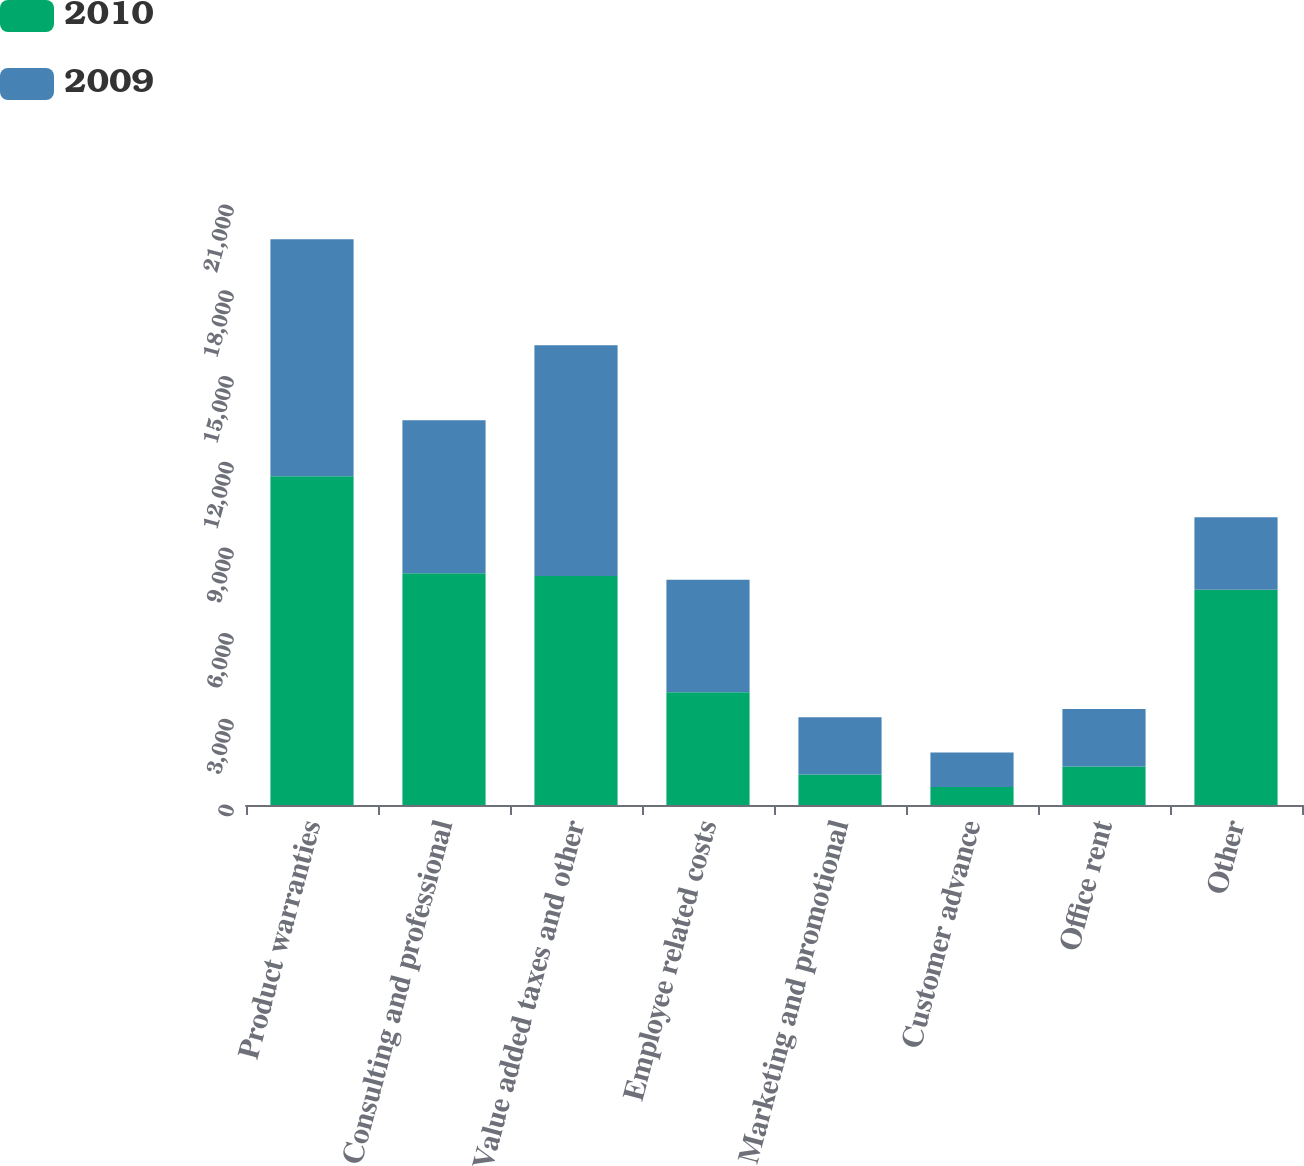<chart> <loc_0><loc_0><loc_500><loc_500><stacked_bar_chart><ecel><fcel>Product warranties<fcel>Consulting and professional<fcel>Value added taxes and other<fcel>Employee related costs<fcel>Marketing and promotional<fcel>Customer advance<fcel>Office rent<fcel>Other<nl><fcel>2010<fcel>11507<fcel>8115<fcel>8013<fcel>3942.5<fcel>1065<fcel>626<fcel>1347<fcel>7535<nl><fcel>2009<fcel>8295<fcel>5352<fcel>8075<fcel>3942.5<fcel>2009<fcel>1210<fcel>2014<fcel>2533<nl></chart> 